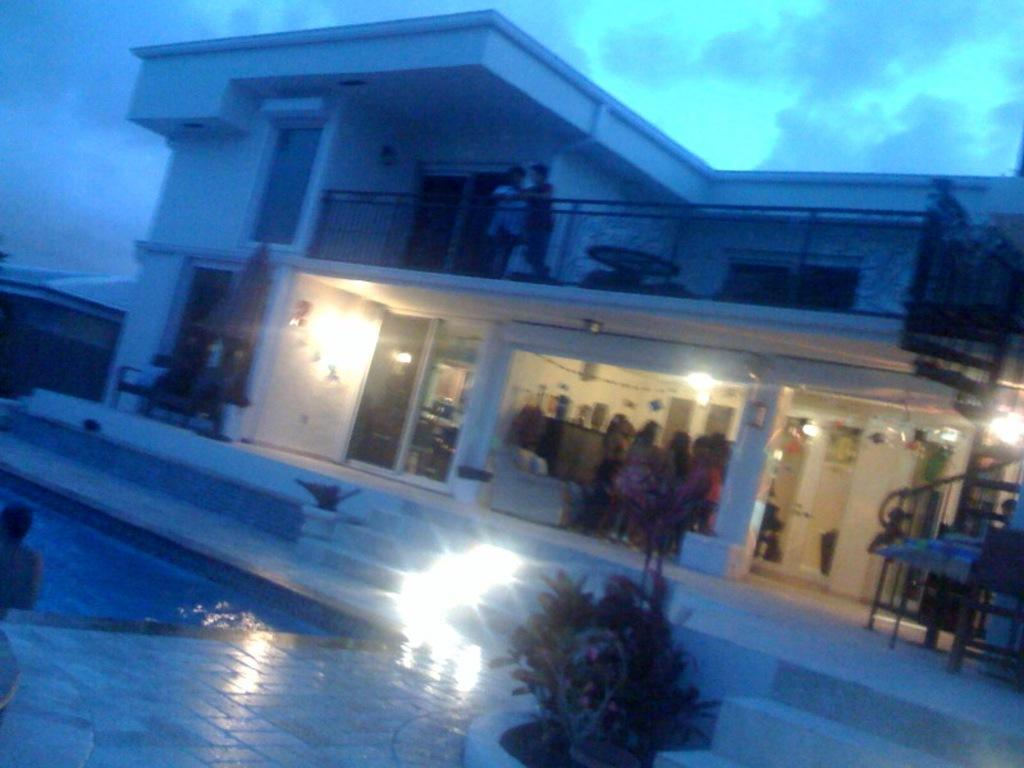What type of structure can be seen in the image? There is a building in the image. What feature is present near the building? There is a swimming pool in the image. What part of the building is visible in the image? The floor is visible in the image. Are there any architectural elements in the image? Yes, there are steps in the image. What else can be seen in the image besides the building and swimming pool? There are plants, lights, people, and objects in the image. What is visible in the background of the image? The sky is visible in the background of the image. What type of drum can be seen being played by the daughter in the image? There is no drum or daughter present in the image. How does the motion of the people in the image change over time? The image is a still photograph, so the motion of the people cannot be observed or described in terms of change over time. 